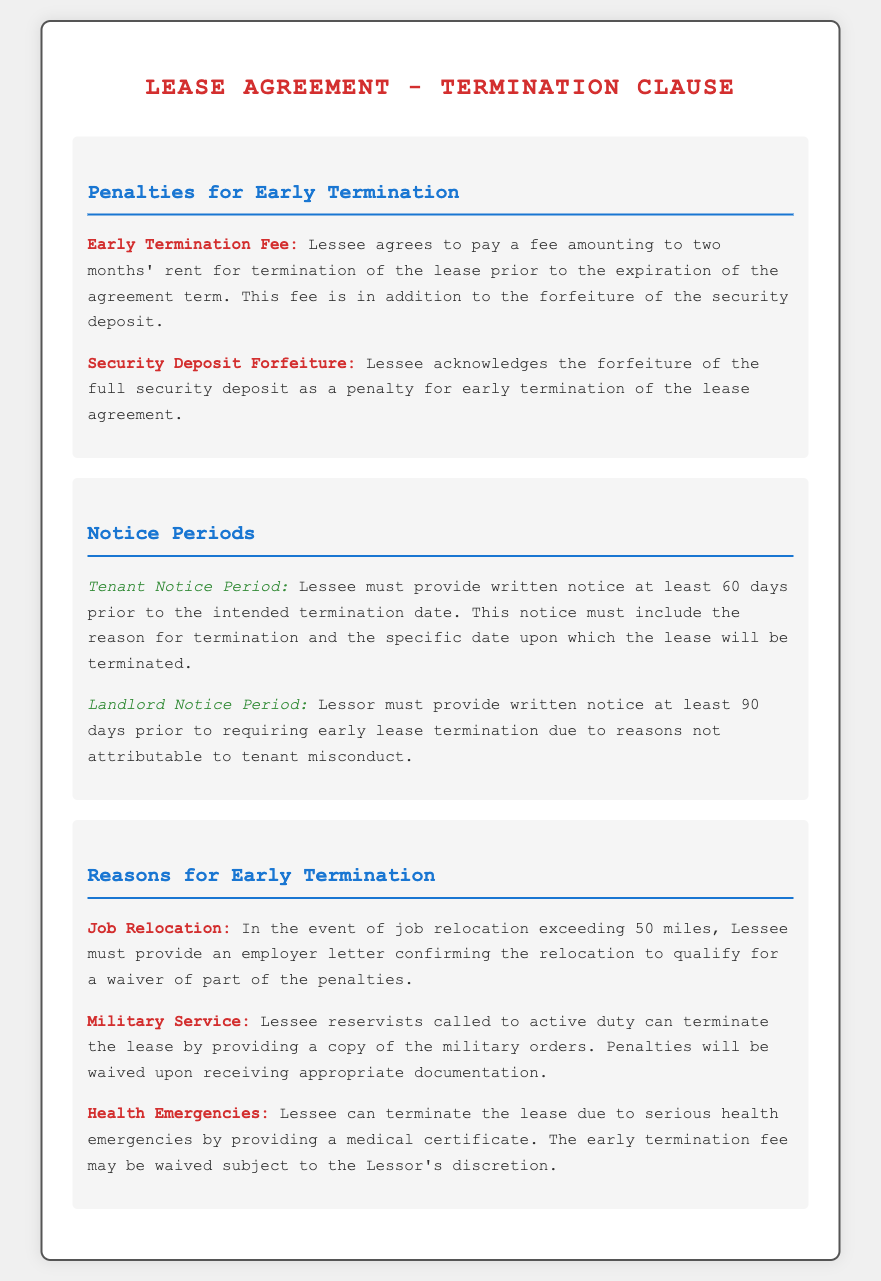What is the early termination fee? The early termination fee is specified in the document, amounting to two months' rent for terminating the lease prior to the expiration of the agreement term.
Answer: two months' rent What is the notice period the lessee must provide? The document specifies that the lessee must provide written notice at least 60 days prior to the intended termination date.
Answer: 60 days What happens to the security deposit upon early termination? The document states that the lessee acknowledges the forfeiture of the full security deposit as a penalty for early termination of the lease agreement.
Answer: forfeiture What is the notice period the lessor must provide? The lessor must provide written notice at least 90 days prior to requiring early lease termination, according to the document.
Answer: 90 days What documentation is needed for job relocation to qualify for a penalty waiver? The document mentions that the lessee must provide an employer letter confirming the relocation for a waiver of part of the penalties.
Answer: employer letter What can trigger early termination without penalties for military service? Lessee reservists called to active duty can terminate the lease with the appropriate documentation, as stated in the document.
Answer: military orders What is one reason that allows for early lease termination due to health issues? The document states that a serious health emergency allows for lease termination, given that a medical certificate is provided.
Answer: medical certificate What is one factor considered for waiving the early termination fee at the lessor's discretion? The document mentions that the early termination fee may be waived due to serious health emergencies, subject to the lessor's discretion.
Answer: lessor's discretion 